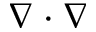<formula> <loc_0><loc_0><loc_500><loc_500>\nabla \cdot \nabla</formula> 